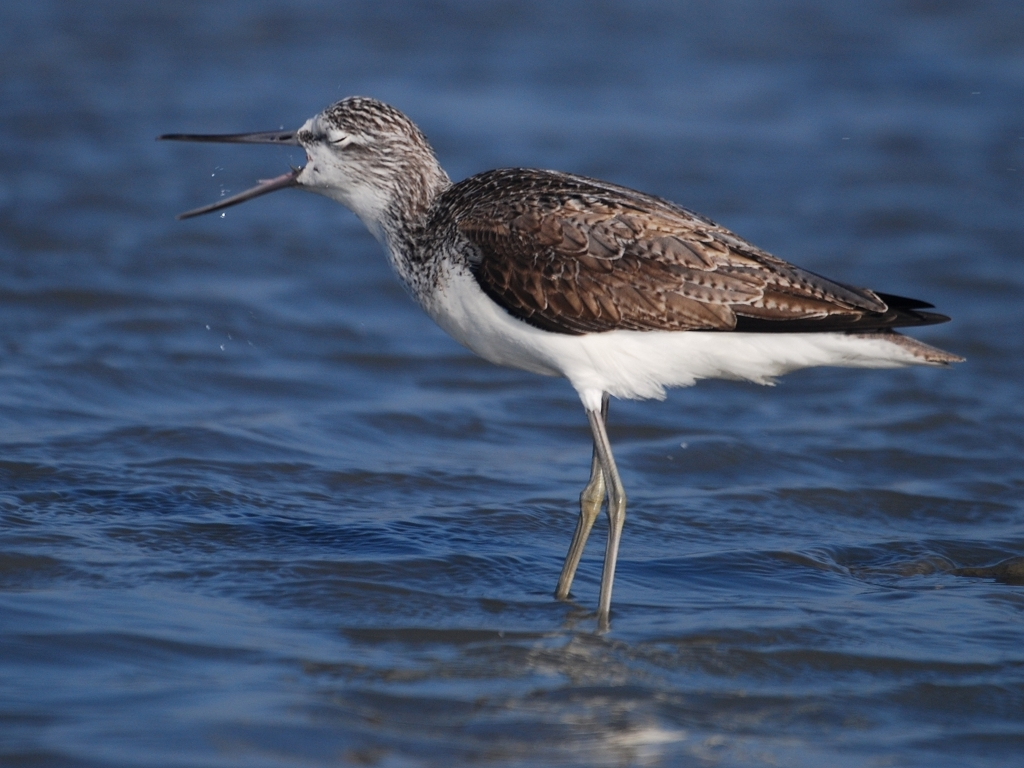Are there any quality issues with this image? The image is of high quality with good focus on the bird, displaying fine detail in its feathers and capturing a behavior moment. There are no apparent quality issues such as blurriness or pixelation. 